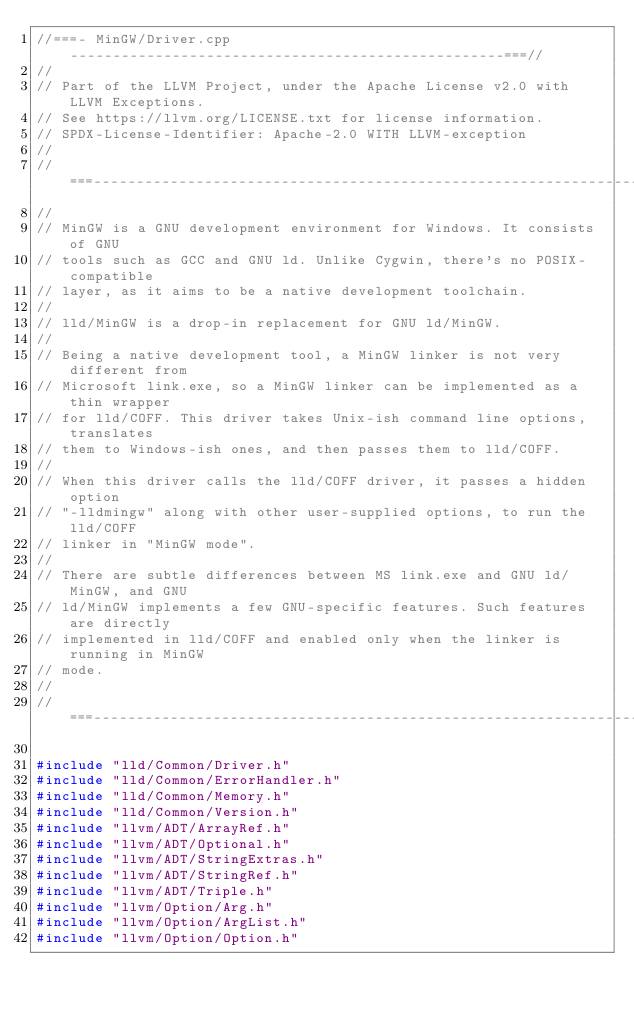<code> <loc_0><loc_0><loc_500><loc_500><_C++_>//===- MinGW/Driver.cpp ---------------------------------------------------===//
//
// Part of the LLVM Project, under the Apache License v2.0 with LLVM Exceptions.
// See https://llvm.org/LICENSE.txt for license information.
// SPDX-License-Identifier: Apache-2.0 WITH LLVM-exception
//
//===----------------------------------------------------------------------===//
//
// MinGW is a GNU development environment for Windows. It consists of GNU
// tools such as GCC and GNU ld. Unlike Cygwin, there's no POSIX-compatible
// layer, as it aims to be a native development toolchain.
//
// lld/MinGW is a drop-in replacement for GNU ld/MinGW.
//
// Being a native development tool, a MinGW linker is not very different from
// Microsoft link.exe, so a MinGW linker can be implemented as a thin wrapper
// for lld/COFF. This driver takes Unix-ish command line options, translates
// them to Windows-ish ones, and then passes them to lld/COFF.
//
// When this driver calls the lld/COFF driver, it passes a hidden option
// "-lldmingw" along with other user-supplied options, to run the lld/COFF
// linker in "MinGW mode".
//
// There are subtle differences between MS link.exe and GNU ld/MinGW, and GNU
// ld/MinGW implements a few GNU-specific features. Such features are directly
// implemented in lld/COFF and enabled only when the linker is running in MinGW
// mode.
//
//===----------------------------------------------------------------------===//

#include "lld/Common/Driver.h"
#include "lld/Common/ErrorHandler.h"
#include "lld/Common/Memory.h"
#include "lld/Common/Version.h"
#include "llvm/ADT/ArrayRef.h"
#include "llvm/ADT/Optional.h"
#include "llvm/ADT/StringExtras.h"
#include "llvm/ADT/StringRef.h"
#include "llvm/ADT/Triple.h"
#include "llvm/Option/Arg.h"
#include "llvm/Option/ArgList.h"
#include "llvm/Option/Option.h"</code> 